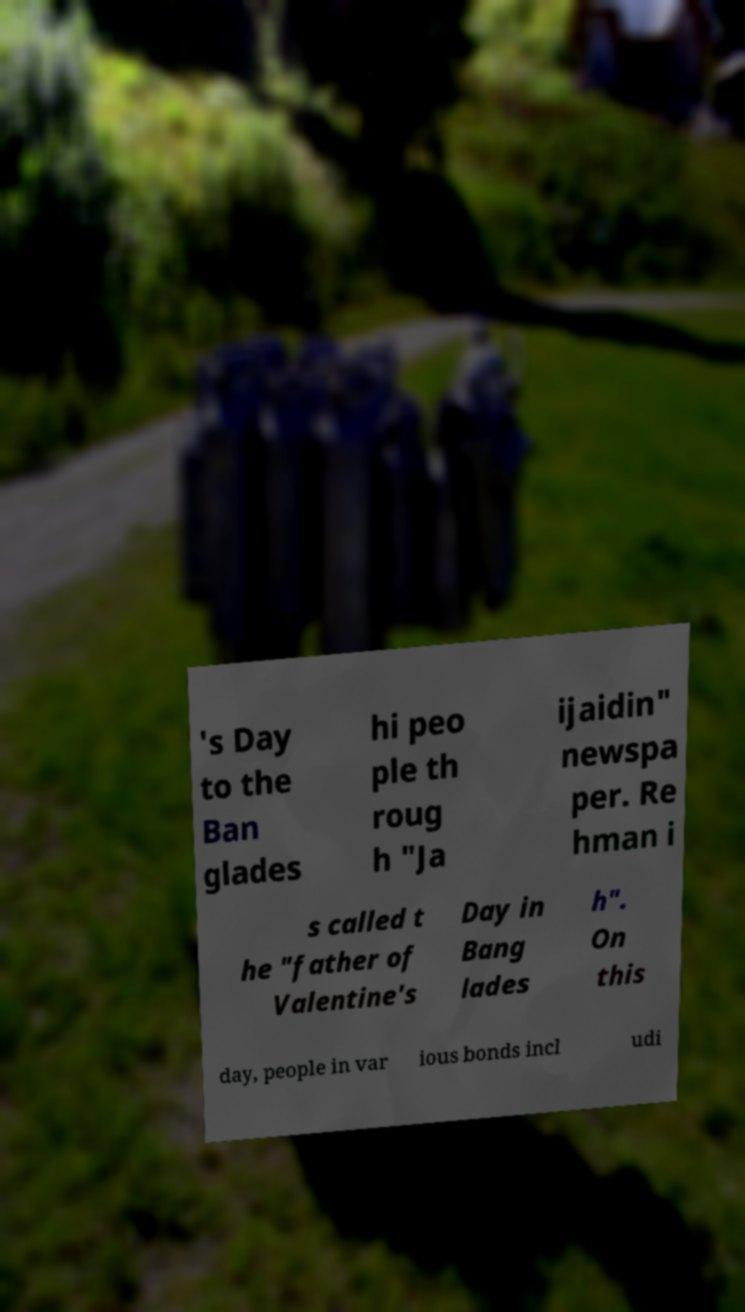Can you accurately transcribe the text from the provided image for me? 's Day to the Ban glades hi peo ple th roug h "Ja ijaidin" newspa per. Re hman i s called t he "father of Valentine's Day in Bang lades h". On this day, people in var ious bonds incl udi 